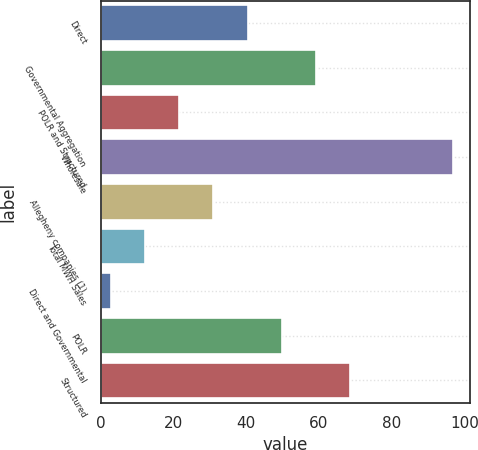Convert chart to OTSL. <chart><loc_0><loc_0><loc_500><loc_500><bar_chart><fcel>Direct<fcel>Governmental Aggregation<fcel>POLR and Structured<fcel>Wholesale<fcel>Allegheny companies (1)<fcel>Total MWH Sales<fcel>Direct and Governmental<fcel>POLR<fcel>Structured<nl><fcel>40.36<fcel>59.14<fcel>21.58<fcel>96.7<fcel>30.97<fcel>12.19<fcel>2.8<fcel>49.75<fcel>68.53<nl></chart> 